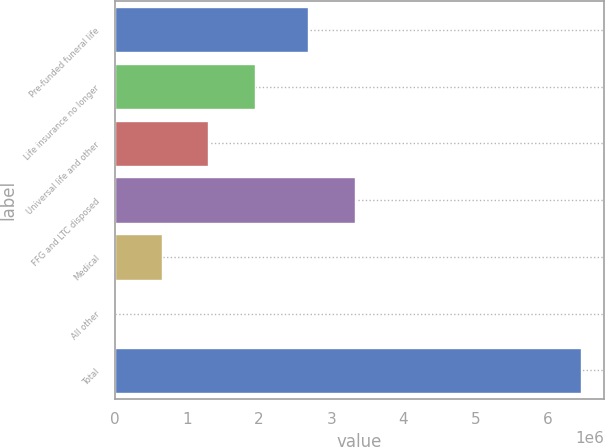<chart> <loc_0><loc_0><loc_500><loc_500><bar_chart><fcel>Pre-funded funeral life<fcel>Life insurance no longer<fcel>Universal life and other<fcel>FFG and LTC disposed<fcel>Medical<fcel>All other<fcel>Total<nl><fcel>2.68395e+06<fcel>1.94059e+06<fcel>1.29558e+06<fcel>3.32897e+06<fcel>650560<fcel>5543<fcel>6.45571e+06<nl></chart> 